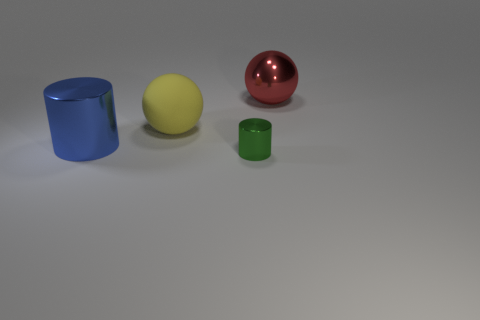How many things are large rubber objects that are in front of the red metal sphere or spheres left of the green shiny object?
Your answer should be very brief. 1. The blue cylinder that is made of the same material as the red ball is what size?
Provide a short and direct response. Large. Is the shape of the thing that is to the right of the small cylinder the same as  the large blue shiny thing?
Offer a terse response. No. What number of red objects are big things or spheres?
Keep it short and to the point. 1. What number of other things are there of the same shape as the blue metallic thing?
Provide a succinct answer. 1. What is the shape of the shiny object that is both in front of the large matte ball and on the right side of the matte object?
Provide a short and direct response. Cylinder. There is a blue metal cylinder; are there any big yellow spheres to the left of it?
Ensure brevity in your answer.  No. There is another object that is the same shape as the matte thing; what is its size?
Keep it short and to the point. Large. Is there any other thing that has the same size as the green cylinder?
Your response must be concise. No. Is the big rubber thing the same shape as the big red shiny thing?
Your answer should be compact. Yes. 